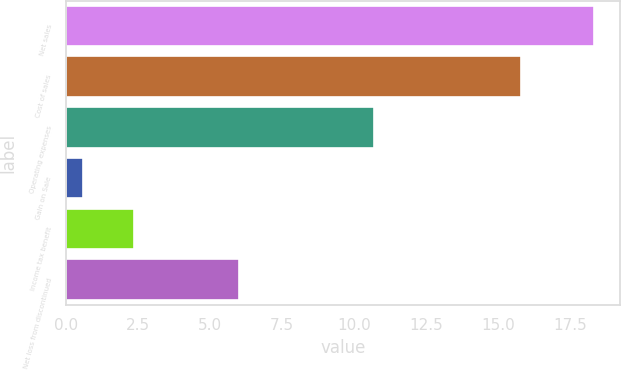Convert chart to OTSL. <chart><loc_0><loc_0><loc_500><loc_500><bar_chart><fcel>Net sales<fcel>Cost of sales<fcel>Operating expenses<fcel>Gain on Sale<fcel>Income tax benefit<fcel>Net loss from discontinued<nl><fcel>18.3<fcel>15.8<fcel>10.7<fcel>0.6<fcel>2.37<fcel>6<nl></chart> 